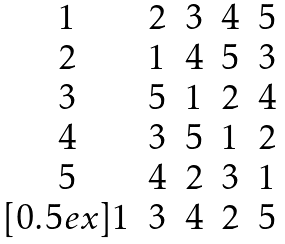<formula> <loc_0><loc_0><loc_500><loc_500>\begin{matrix} 1 & 2 & 3 & 4 & 5 \\ 2 & 1 & 4 & 5 & 3 \\ 3 & 5 & 1 & 2 & 4 \\ 4 & 3 & 5 & 1 & 2 \\ 5 & 4 & 2 & 3 & 1 \\ [ 0 . 5 e x ] 1 & 3 & 4 & 2 & 5 \end{matrix}</formula> 